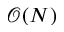Convert formula to latex. <formula><loc_0><loc_0><loc_500><loc_500>\mathcal { O } ( N )</formula> 